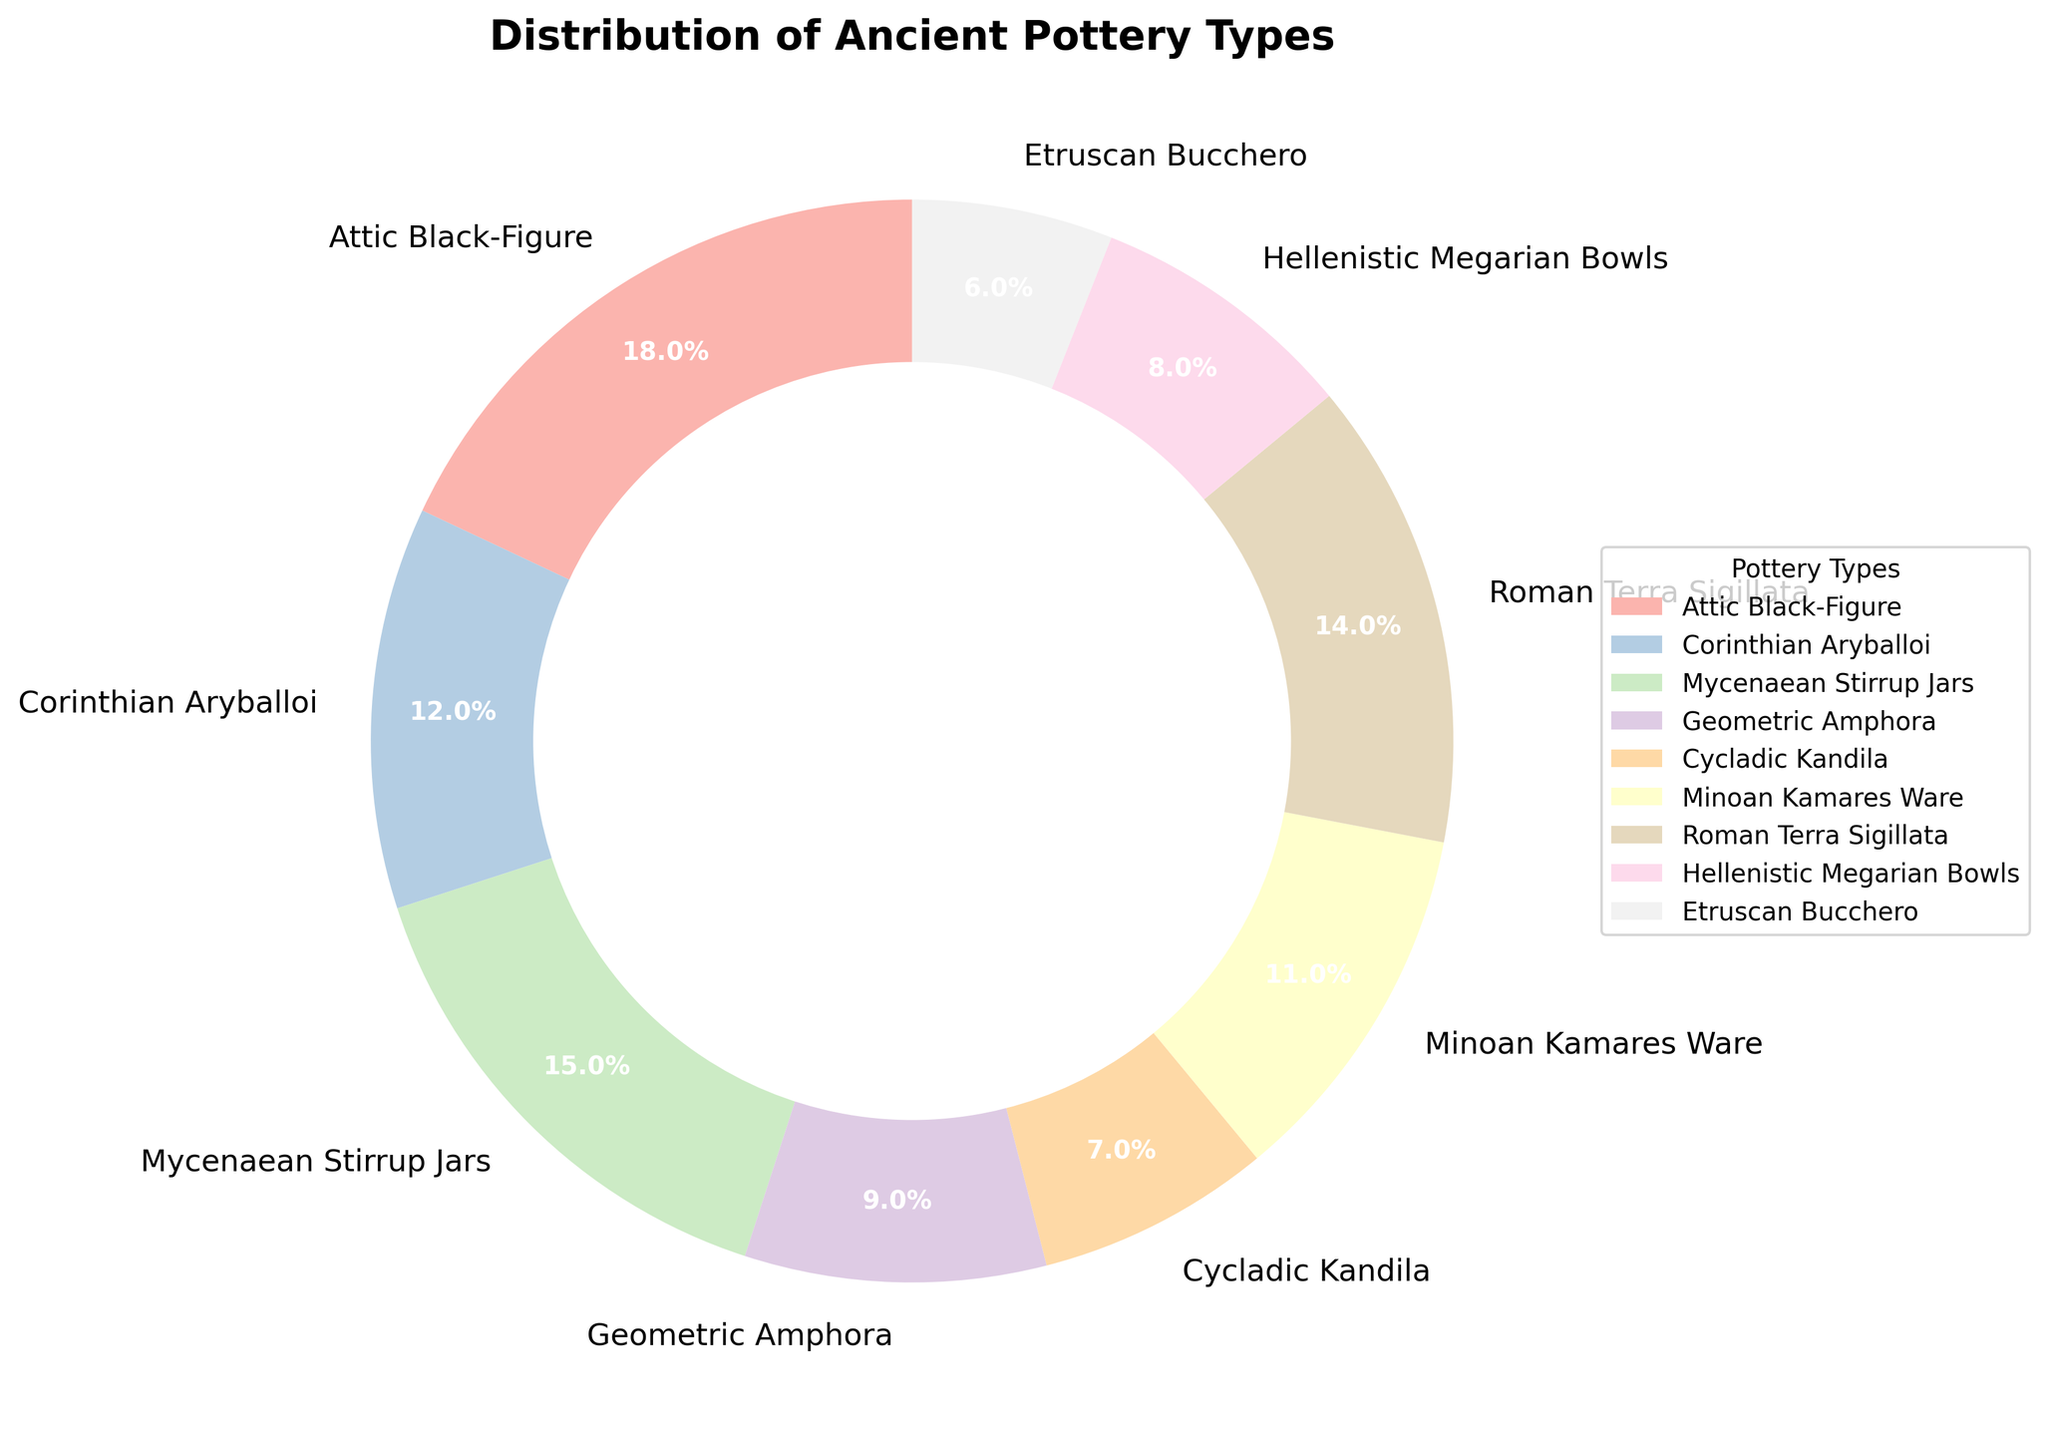What percentage of the pottery types does the Attic Black-Figure represent? The figure shows the Attic Black-Figure pottery type has a percentage value. Simply reading the label shows it represents 18%.
Answer: 18% Which pottery type has the smallest percentage? To identify this, look through the percentage values of each pottery type. The smallest percentage value in the figure is 6%, corresponding to Etruscan Bucchero pottery.
Answer: Etruscan Bucchero What is the combined percentage of Mycenaean Stirrup Jars and Roman Terra Sigillata? Add the percentages of Mycenaean Stirrup Jars (15%) and Roman Terra Sigillata (14%). 15 + 14 results in a combined percentage of 29%.
Answer: 29% How does the percentage of Corinthian Aryballoi compare to Hellenistic Megarian Bowls? Compare the two percentages directly from the figure: Corinthian Aryballoi is 12% and Hellenistic Megarian Bowls are 8%. Corinthian Aryballoi is therefore larger.
Answer: Corinthian Aryballoi is larger What is the difference in percentage between Attic Black-Figure and Geometric Amphora? Subtract the percentage of Geometric Amphora (9%) from Attic Black-Figure (18%). 18 - 9 equals 9%.
Answer: 9% Which three pottery types collectively make up approximately 36% of the findings? To determine this, look for combinations of percentages that sum up to approximately 36%. Attic Black-Figure (18%), Hellenistic Megarian Bowls (8%), and Corinthian Aryballoi (12%) collectively sum to 38%, but Minoan Kamares Ware (11%), Hellenistic Megarian Bowls (8%), and Corinthian Aryballoi (12%) sum to approximately 31%. The closest combination is Mycenaean Stirrup Jars (15%), Corinthian Aryballoi (12%), and Geometric Amphora (9%), which collectively make 36%.
Answer: Mycenaean Stirrup Jars, Corinthian Aryballoi, Geometric Amphora Which pottery types exceed 10% each? Identify pottery types with percentages over 10%: Attic Black-Figure (18%), Mycenaean Stirrup Jars (15%), Roman Terra Sigillata (14%), Coralithian Aryballoi (12%), and Minoan Kamares Ware (11%).
Answer: Attic Black-Figure, Mycenaean Stirrup Jars, Roman Terra Sigillata, Corinthian Aryballoi, Minoan Kamares Ware Which pottery type is almost twice the percentage of Cycladic Kandila? Look at Cycladic Kandila's percentage (7%) and find a type close to twice this value. Mycenaean Stirrup Jars (15%) is close, but the closest fit is Attic Black-Figure (18%). 18% is more than twice 7%.
Answer: Attic Black-Figure What percentage is both Cycladic Kandila and Etruscan Bucchero combined? Cycladic Kandila is 7%, and Etruscan Bucchero is 6%. Add these percentages: 7 + 6 equals 13%.
Answer: 13% 